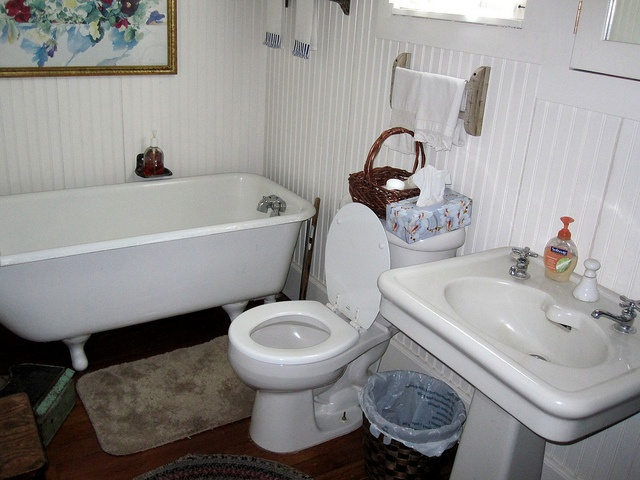Describe the objects in this image and their specific colors. I can see sink in gray, darkgray, lightgray, and black tones, toilet in gray, darkgray, and lightgray tones, and bottle in gray, brown, and darkgray tones in this image. 